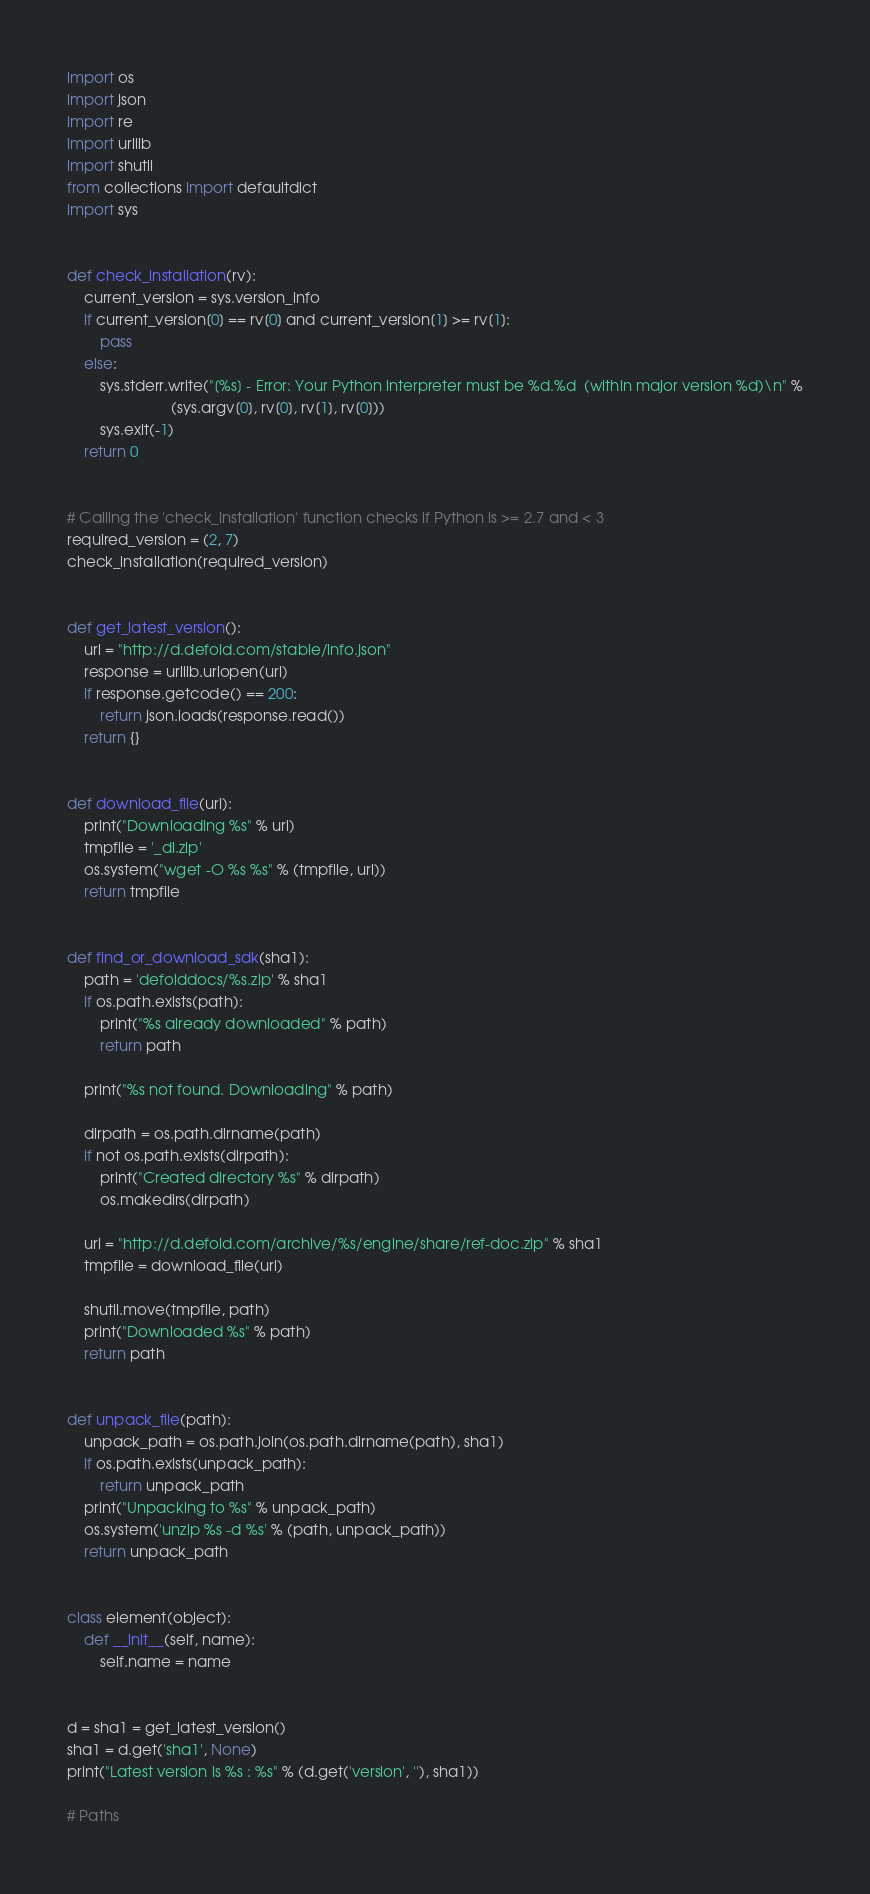Convert code to text. <code><loc_0><loc_0><loc_500><loc_500><_Python_>import os
import json
import re
import urllib
import shutil
from collections import defaultdict
import sys


def check_installation(rv):
    current_version = sys.version_info
    if current_version[0] == rv[0] and current_version[1] >= rv[1]:
        pass
    else:
        sys.stderr.write("[%s] - Error: Your Python interpreter must be %d.%d  (within major version %d)\n" %
                         (sys.argv[0], rv[0], rv[1], rv[0]))
        sys.exit(-1)
    return 0


# Calling the 'check_installation' function checks if Python is >= 2.7 and < 3
required_version = (2, 7)
check_installation(required_version)


def get_latest_version():
    url = "http://d.defold.com/stable/info.json"
    response = urllib.urlopen(url)
    if response.getcode() == 200:
        return json.loads(response.read())
    return {}


def download_file(url):
    print("Downloading %s" % url)
    tmpfile = '_dl.zip'
    os.system("wget -O %s %s" % (tmpfile, url))
    return tmpfile


def find_or_download_sdk(sha1):
    path = 'defolddocs/%s.zip' % sha1
    if os.path.exists(path):
        print("%s already downloaded" % path)
        return path

    print("%s not found. Downloading" % path)

    dirpath = os.path.dirname(path)
    if not os.path.exists(dirpath):
        print("Created directory %s" % dirpath)
        os.makedirs(dirpath)

    url = "http://d.defold.com/archive/%s/engine/share/ref-doc.zip" % sha1
    tmpfile = download_file(url)

    shutil.move(tmpfile, path)
    print("Downloaded %s" % path)
    return path


def unpack_file(path):
    unpack_path = os.path.join(os.path.dirname(path), sha1)
    if os.path.exists(unpack_path):
        return unpack_path
    print("Unpacking to %s" % unpack_path)
    os.system('unzip %s -d %s' % (path, unpack_path))
    return unpack_path


class element(object):
    def __init__(self, name):
        self.name = name


d = sha1 = get_latest_version()
sha1 = d.get('sha1', None)
print("Latest version is %s : %s" % (d.get('version', ''), sha1))

# Paths</code> 